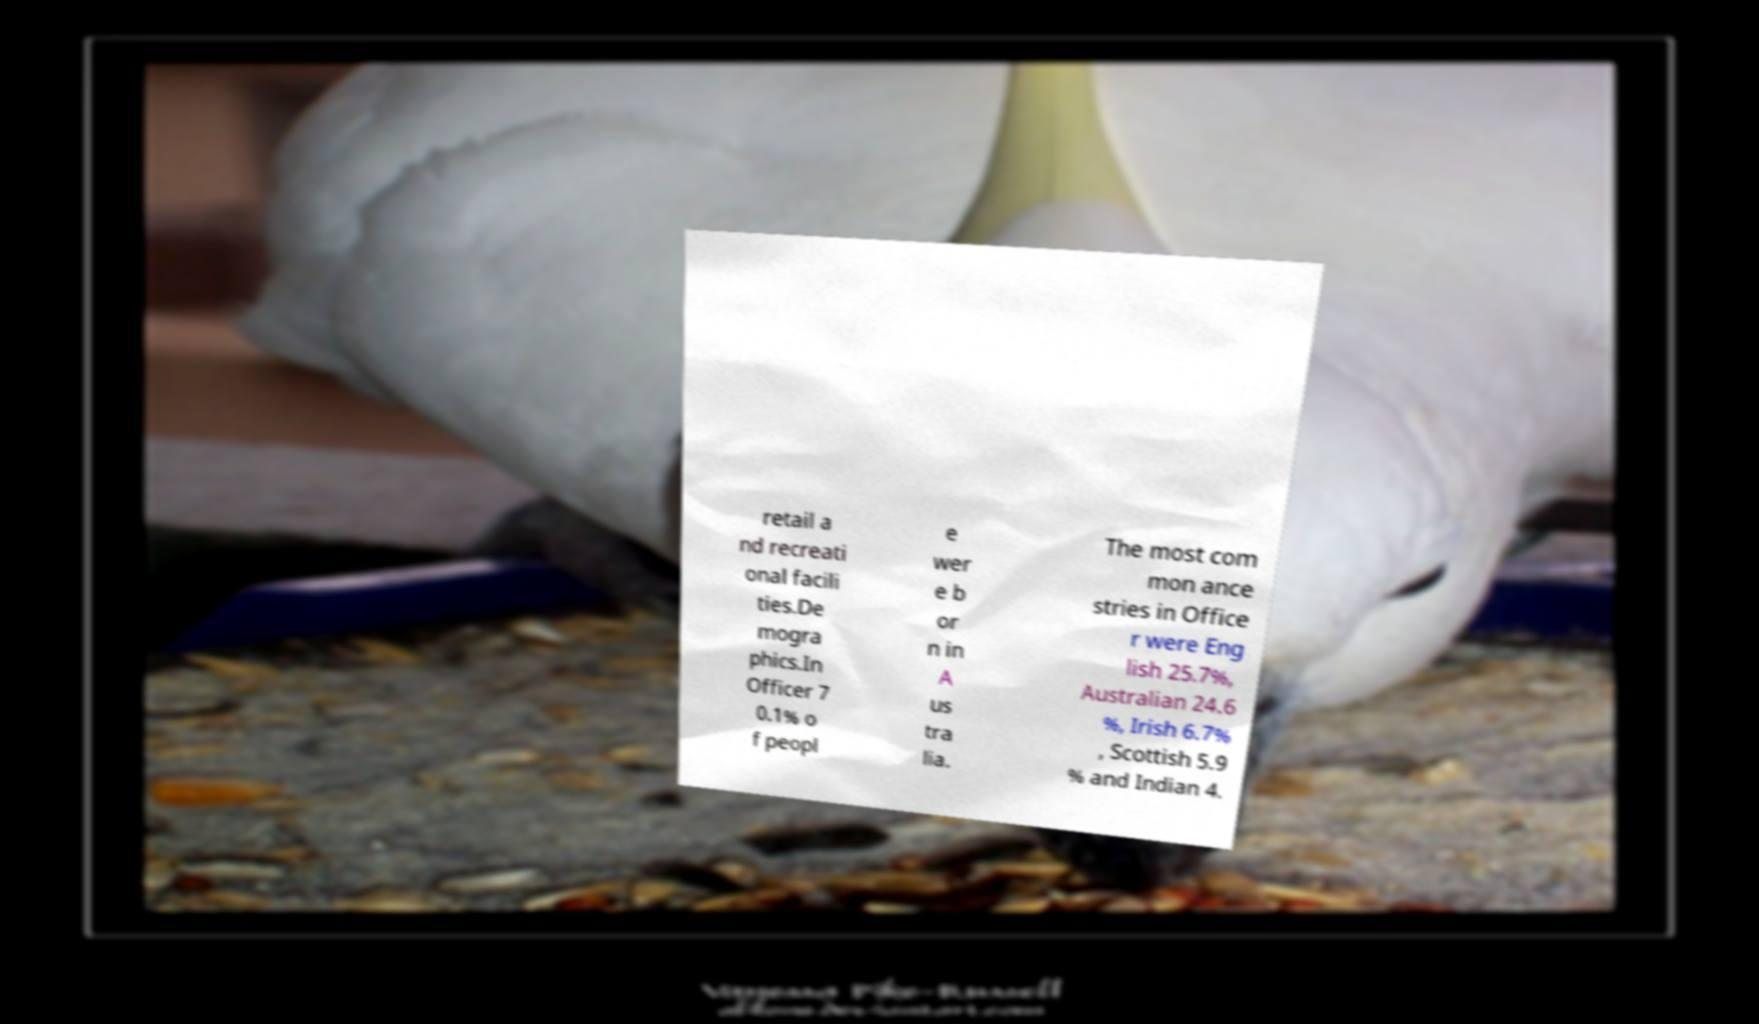Can you accurately transcribe the text from the provided image for me? retail a nd recreati onal facili ties.De mogra phics.In Officer 7 0.1% o f peopl e wer e b or n in A us tra lia. The most com mon ance stries in Office r were Eng lish 25.7%, Australian 24.6 %, Irish 6.7% , Scottish 5.9 % and Indian 4. 